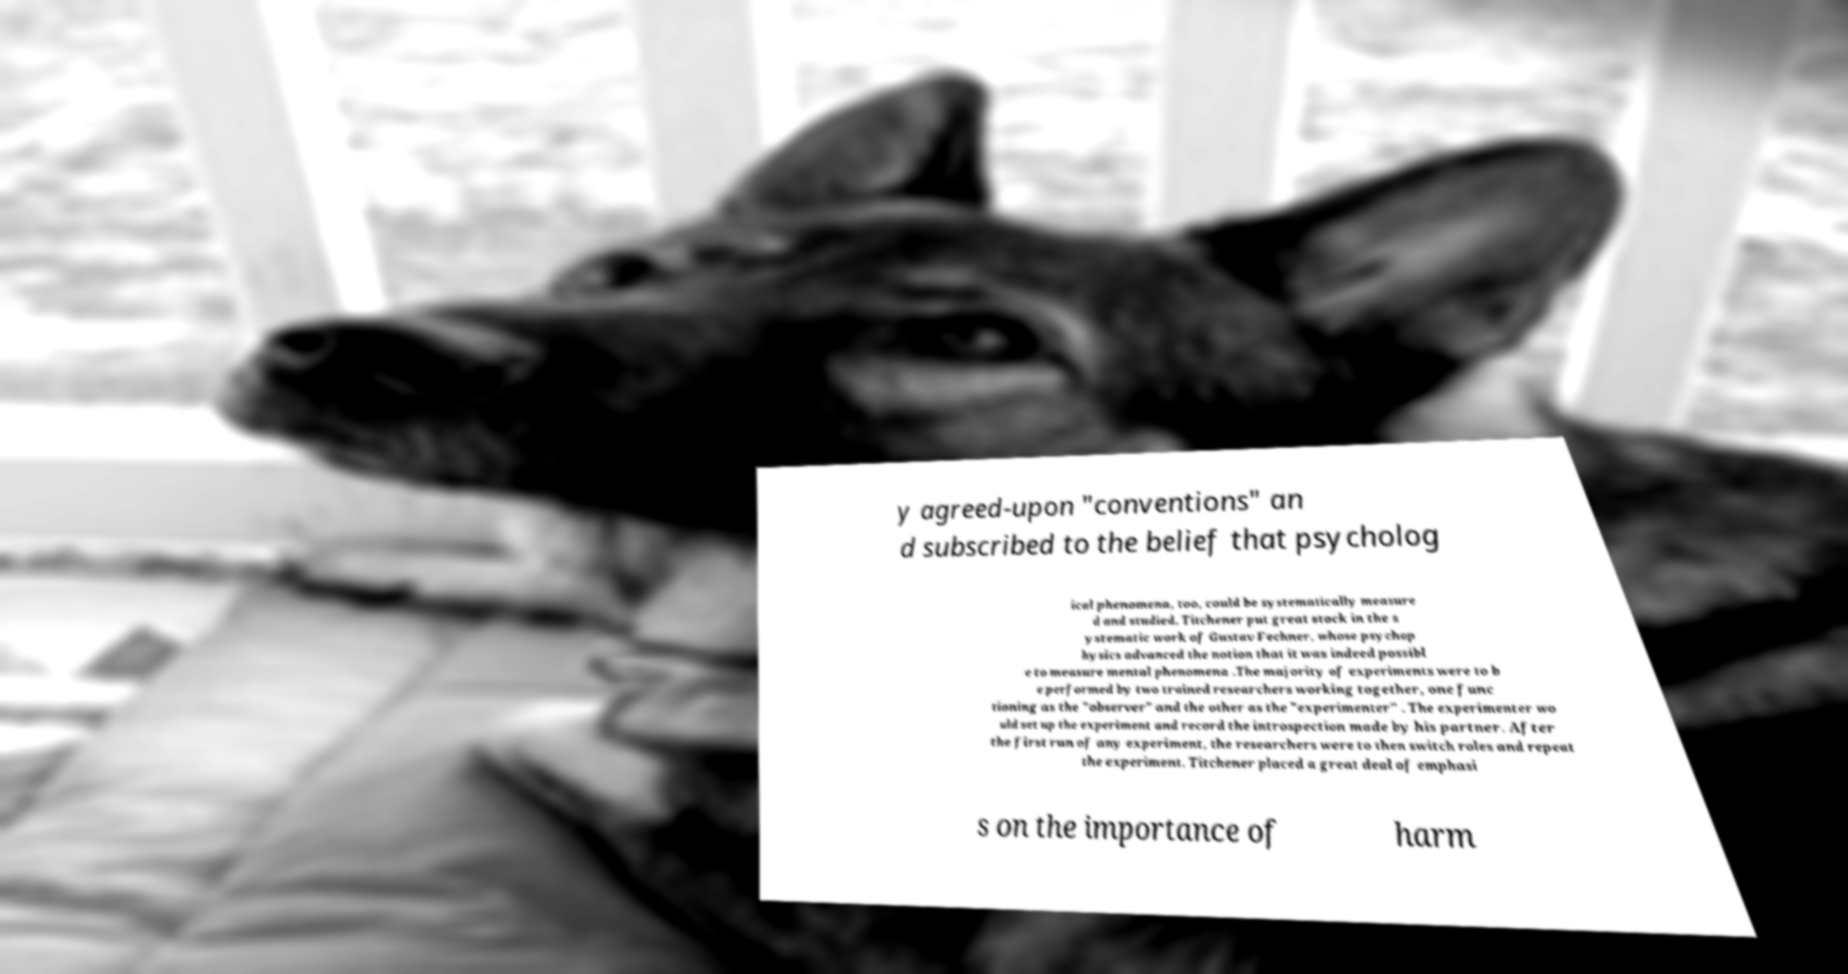For documentation purposes, I need the text within this image transcribed. Could you provide that? y agreed-upon "conventions" an d subscribed to the belief that psycholog ical phenomena, too, could be systematically measure d and studied. Titchener put great stock in the s ystematic work of Gustav Fechner, whose psychop hysics advanced the notion that it was indeed possibl e to measure mental phenomena .The majority of experiments were to b e performed by two trained researchers working together, one func tioning as the "observer" and the other as the "experimenter" . The experimenter wo uld set up the experiment and record the introspection made by his partner. After the first run of any experiment, the researchers were to then switch roles and repeat the experiment. Titchener placed a great deal of emphasi s on the importance of harm 